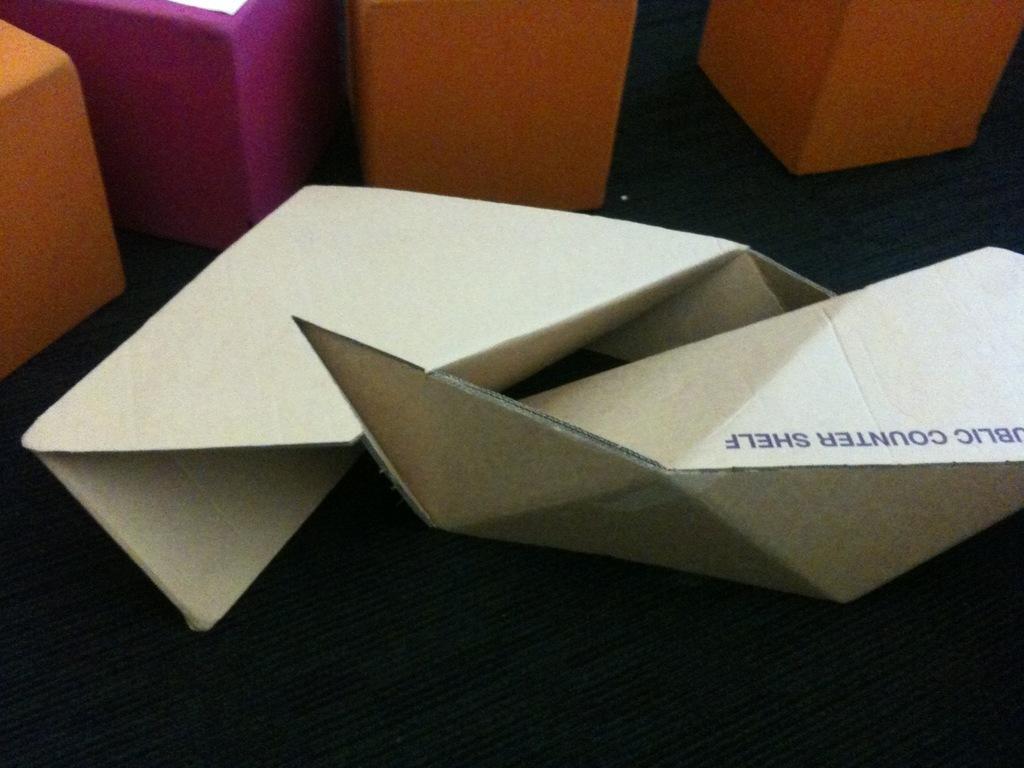Describe this image in one or two sentences. In this image I can see boxes and cardboard crafts on the floor. This image is taken may be in a hall. 